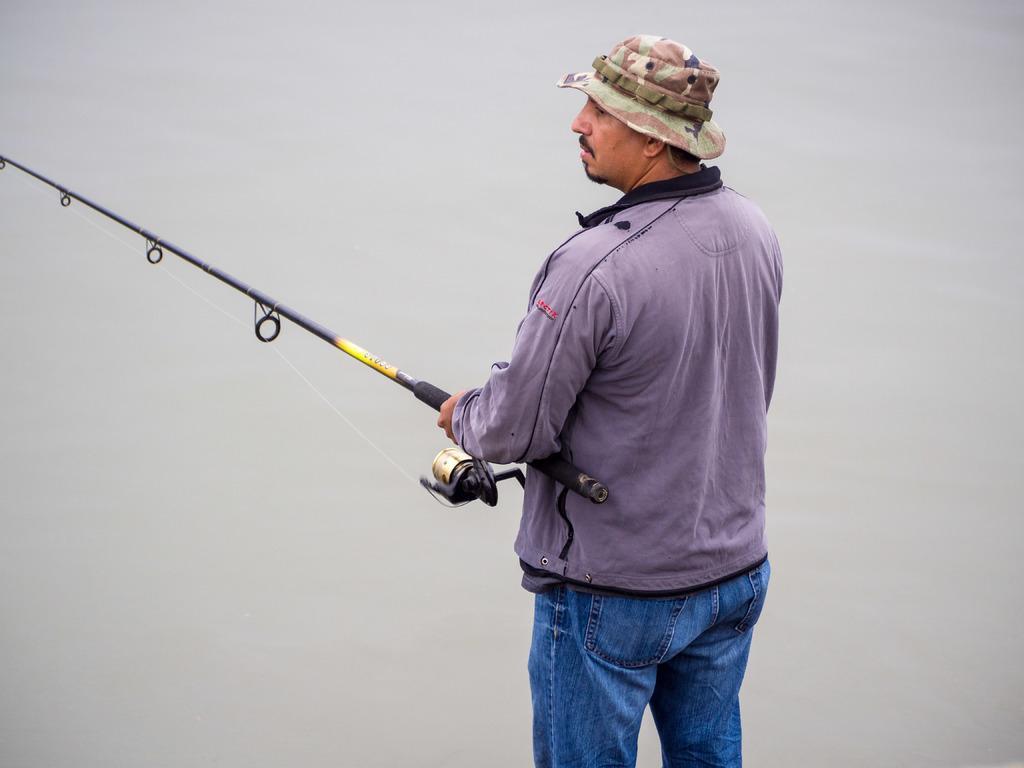Describe this image in one or two sentences. In the center of the image we can see a man standing and holding a fishing rod. 